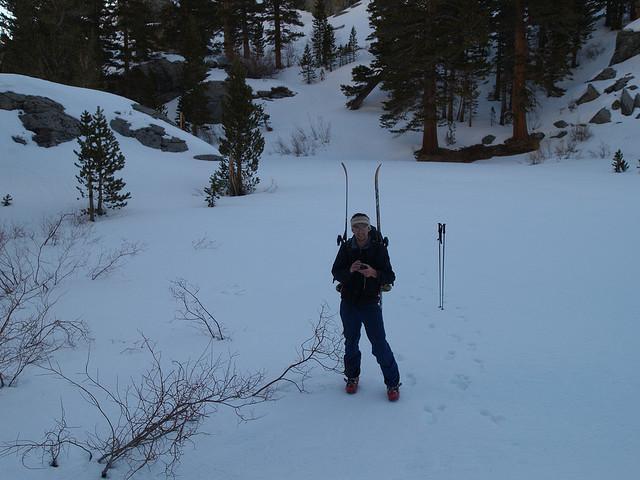How many people are walking?
Give a very brief answer. 1. How many kites are flying?
Give a very brief answer. 0. 